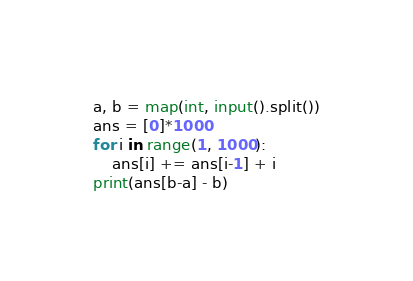<code> <loc_0><loc_0><loc_500><loc_500><_Python_>a, b = map(int, input().split())
ans = [0]*1000
for i in range(1, 1000):
    ans[i] += ans[i-1] + i
print(ans[b-a] - b)</code> 